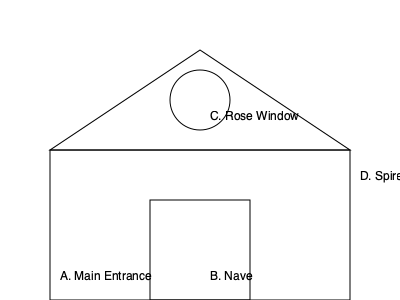Which architectural feature of Trinity Episcopal Church is typically associated with Gothic Revival style and allows natural light to illuminate the interior? To answer this question, let's examine the architectural features shown in the diagram:

1. Main Entrance (A): This is the primary point of entry for the church but is not specifically associated with Gothic Revival style or natural lighting.

2. Nave (B): This is the central part of the church where the congregation sits. While important, it's not a distinctive Gothic Revival feature or primarily responsible for natural lighting.

3. Rose Window (C): This is a circular window, often with intricate tracery, that is a hallmark of Gothic and Gothic Revival architecture. Rose windows are typically placed high on the facade or transepts of a church and allow significant natural light to enter, creating a beautiful illumination effect inside.

4. Spire (D): While spires are common in Gothic Revival churches, they are exterior features and do not contribute to interior lighting.

The Rose Window (C) is the architectural element that best fits the description in the question. It is a key feature of Gothic Revival style and serves the important function of allowing natural light to illuminate the church interior.
Answer: Rose Window 